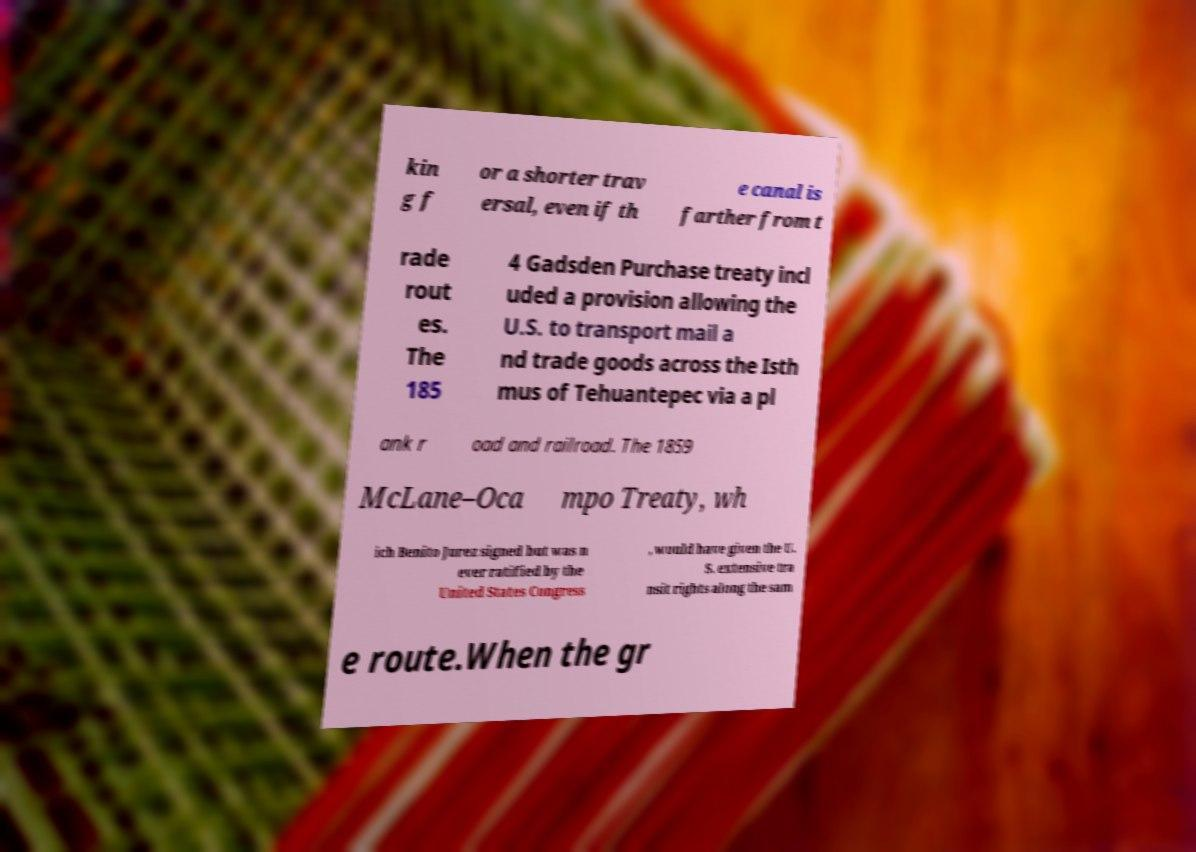What messages or text are displayed in this image? I need them in a readable, typed format. kin g f or a shorter trav ersal, even if th e canal is farther from t rade rout es. The 185 4 Gadsden Purchase treaty incl uded a provision allowing the U.S. to transport mail a nd trade goods across the Isth mus of Tehuantepec via a pl ank r oad and railroad. The 1859 McLane–Oca mpo Treaty, wh ich Benito Jurez signed but was n ever ratified by the United States Congress , would have given the U. S. extensive tra nsit rights along the sam e route.When the gr 